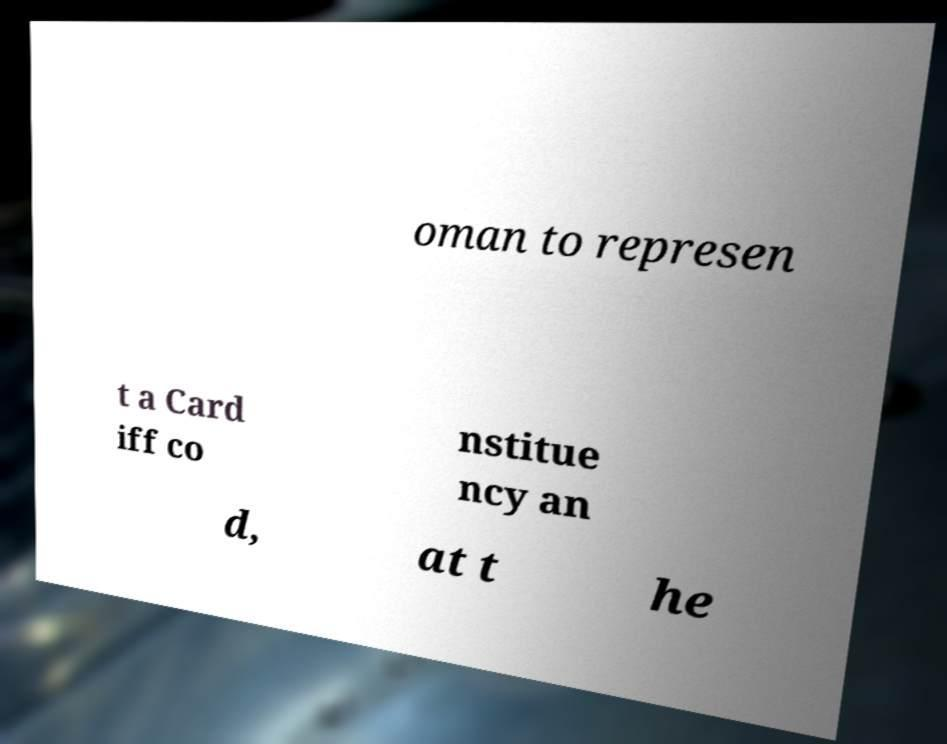Please identify and transcribe the text found in this image. oman to represen t a Card iff co nstitue ncy an d, at t he 